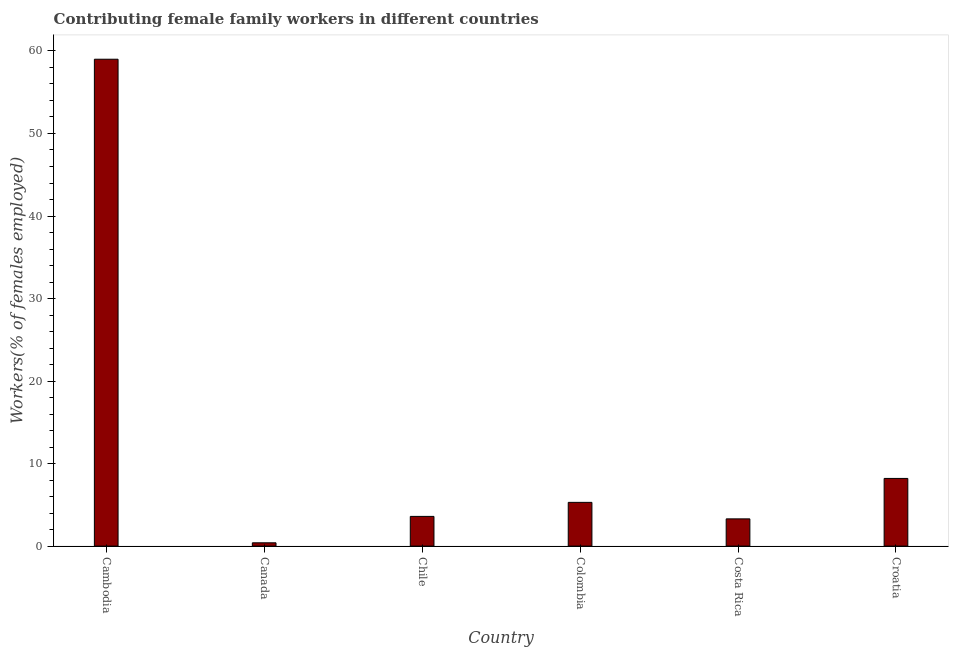What is the title of the graph?
Your answer should be compact. Contributing female family workers in different countries. What is the label or title of the X-axis?
Provide a short and direct response. Country. What is the label or title of the Y-axis?
Offer a terse response. Workers(% of females employed). What is the contributing female family workers in Colombia?
Keep it short and to the point. 5.3. Across all countries, what is the minimum contributing female family workers?
Give a very brief answer. 0.4. In which country was the contributing female family workers maximum?
Your answer should be very brief. Cambodia. What is the sum of the contributing female family workers?
Your answer should be very brief. 79.8. What is the difference between the contributing female family workers in Colombia and Croatia?
Give a very brief answer. -2.9. What is the average contributing female family workers per country?
Give a very brief answer. 13.3. What is the median contributing female family workers?
Provide a succinct answer. 4.45. In how many countries, is the contributing female family workers greater than 2 %?
Ensure brevity in your answer.  5. What is the ratio of the contributing female family workers in Cambodia to that in Croatia?
Offer a terse response. 7.2. Is the difference between the contributing female family workers in Canada and Colombia greater than the difference between any two countries?
Offer a very short reply. No. What is the difference between the highest and the second highest contributing female family workers?
Ensure brevity in your answer.  50.8. What is the difference between the highest and the lowest contributing female family workers?
Your answer should be compact. 58.6. In how many countries, is the contributing female family workers greater than the average contributing female family workers taken over all countries?
Make the answer very short. 1. How many bars are there?
Offer a terse response. 6. Are all the bars in the graph horizontal?
Make the answer very short. No. How many countries are there in the graph?
Keep it short and to the point. 6. What is the difference between two consecutive major ticks on the Y-axis?
Your answer should be very brief. 10. Are the values on the major ticks of Y-axis written in scientific E-notation?
Ensure brevity in your answer.  No. What is the Workers(% of females employed) in Cambodia?
Your answer should be compact. 59. What is the Workers(% of females employed) in Canada?
Provide a succinct answer. 0.4. What is the Workers(% of females employed) in Chile?
Your response must be concise. 3.6. What is the Workers(% of females employed) of Colombia?
Provide a succinct answer. 5.3. What is the Workers(% of females employed) in Costa Rica?
Your answer should be very brief. 3.3. What is the Workers(% of females employed) of Croatia?
Your answer should be compact. 8.2. What is the difference between the Workers(% of females employed) in Cambodia and Canada?
Give a very brief answer. 58.6. What is the difference between the Workers(% of females employed) in Cambodia and Chile?
Give a very brief answer. 55.4. What is the difference between the Workers(% of females employed) in Cambodia and Colombia?
Your answer should be very brief. 53.7. What is the difference between the Workers(% of females employed) in Cambodia and Costa Rica?
Provide a succinct answer. 55.7. What is the difference between the Workers(% of females employed) in Cambodia and Croatia?
Offer a terse response. 50.8. What is the difference between the Workers(% of females employed) in Canada and Costa Rica?
Give a very brief answer. -2.9. What is the difference between the Workers(% of females employed) in Chile and Colombia?
Your answer should be compact. -1.7. What is the difference between the Workers(% of females employed) in Chile and Costa Rica?
Your answer should be compact. 0.3. What is the difference between the Workers(% of females employed) in Colombia and Costa Rica?
Make the answer very short. 2. What is the difference between the Workers(% of females employed) in Colombia and Croatia?
Your answer should be compact. -2.9. What is the difference between the Workers(% of females employed) in Costa Rica and Croatia?
Your response must be concise. -4.9. What is the ratio of the Workers(% of females employed) in Cambodia to that in Canada?
Give a very brief answer. 147.5. What is the ratio of the Workers(% of females employed) in Cambodia to that in Chile?
Your answer should be very brief. 16.39. What is the ratio of the Workers(% of females employed) in Cambodia to that in Colombia?
Your answer should be compact. 11.13. What is the ratio of the Workers(% of females employed) in Cambodia to that in Costa Rica?
Your answer should be compact. 17.88. What is the ratio of the Workers(% of females employed) in Cambodia to that in Croatia?
Make the answer very short. 7.2. What is the ratio of the Workers(% of females employed) in Canada to that in Chile?
Ensure brevity in your answer.  0.11. What is the ratio of the Workers(% of females employed) in Canada to that in Colombia?
Make the answer very short. 0.07. What is the ratio of the Workers(% of females employed) in Canada to that in Costa Rica?
Offer a very short reply. 0.12. What is the ratio of the Workers(% of females employed) in Canada to that in Croatia?
Give a very brief answer. 0.05. What is the ratio of the Workers(% of females employed) in Chile to that in Colombia?
Keep it short and to the point. 0.68. What is the ratio of the Workers(% of females employed) in Chile to that in Costa Rica?
Make the answer very short. 1.09. What is the ratio of the Workers(% of females employed) in Chile to that in Croatia?
Make the answer very short. 0.44. What is the ratio of the Workers(% of females employed) in Colombia to that in Costa Rica?
Offer a terse response. 1.61. What is the ratio of the Workers(% of females employed) in Colombia to that in Croatia?
Offer a very short reply. 0.65. What is the ratio of the Workers(% of females employed) in Costa Rica to that in Croatia?
Provide a succinct answer. 0.4. 